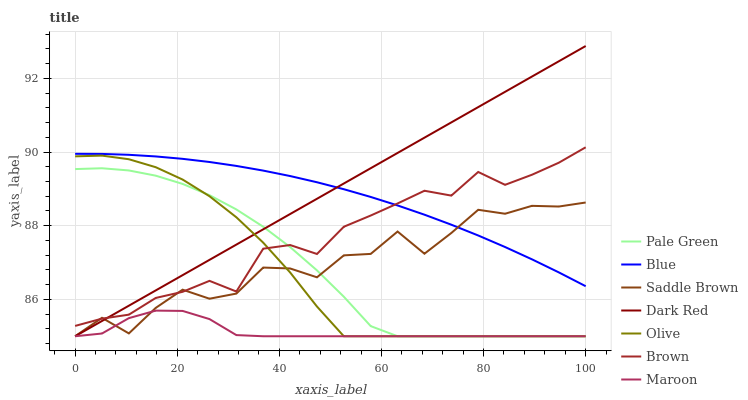Does Brown have the minimum area under the curve?
Answer yes or no. No. Does Brown have the maximum area under the curve?
Answer yes or no. No. Is Brown the smoothest?
Answer yes or no. No. Is Brown the roughest?
Answer yes or no. No. Does Brown have the lowest value?
Answer yes or no. No. Does Brown have the highest value?
Answer yes or no. No. Is Pale Green less than Blue?
Answer yes or no. Yes. Is Blue greater than Pale Green?
Answer yes or no. Yes. Does Pale Green intersect Blue?
Answer yes or no. No. 